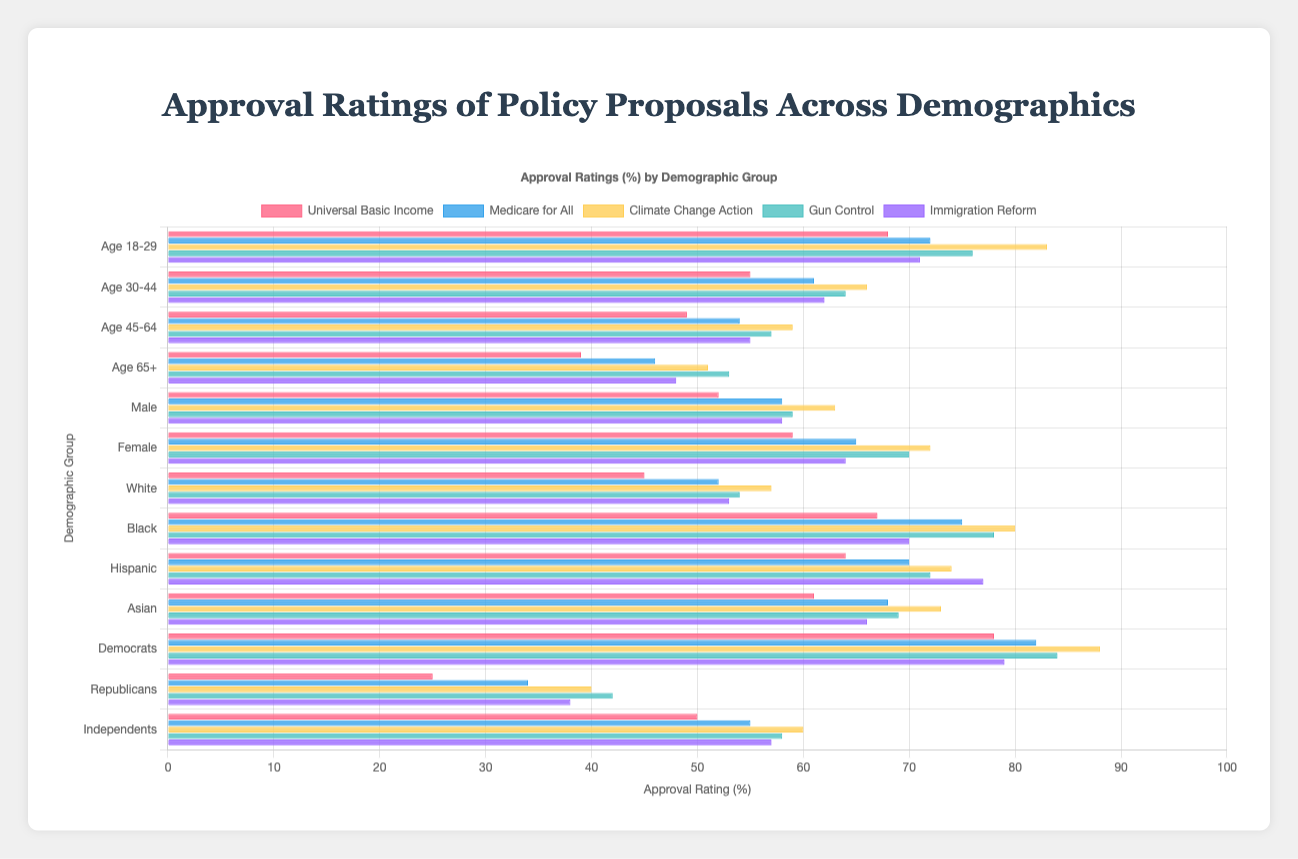What's the demographic group with the highest approval rating for Universal Basic Income? To find the highest approval rating for Universal Basic Income, look at the "Universal Basic Income" policy and then identify the demographic with the highest value, which is found to be "Age 18-29" with 68%.
Answer: Age 18-29 Which policy proposal has the lowest approval rating among Republicans? Identify the approval ratings for Republicans across all policy proposals. The lowest approval rating for Republicans is for "Universal Basic Income" with 25%.
Answer: Universal Basic Income What is the average approval rating for "Climate Change Action" across all age groups? Sum up the approval ratings for "Climate Change Action" across age groups (18-29, 30-44, 45-64, 65+): 83 + 66 + 59 + 51 = 259. Divide this by 4 (the number of age groups): 259 / 4 = 64.75
Answer: 64.75 Which policy has the highest approval rating overall and what is it? Look through the approval ratings for each policy proposal and identify the highest single value across all demographics. "Climate Change Action" has the highest approval rating with "Age 18-29" at 83%.
Answer: Climate Change Action at 83% How much higher is the approval rating for Gun Control among Democrats compared to Republicans? Subtract the approval rating for Republicans from that for Democrats for the "Gun Control" policy: 84% - 42% = 42%
Answer: 42% What is the difference in approval ratings for Medicare for All between males and females? Identify approval ratings for males and females for "Medicare for All". Subtract the male approval rating from the female approval rating: 65% - 58% = 7%
Answer: 7% Which demographic shows the greatest disparity in approval ratings between Medicare for All and Immigration Reform? Calculate the difference in approval ratings for both policies across different demographics and identify the one with the largest gap. The disparity for "Republicans" is the greatest, with a difference of 34% in Medicare for All and 38% in Immigration Reform:
Answer: Republicans (34% - 38%) = -4 What is the range of approval ratings for "Immigration Reform" among all age groups? Identify the highest and lowest approval ratings for "Immigration Reform" across all age demographics. Highest is "Age 18-29" at 71%, lowest is "Age 65+" at 48%. The range is 71% - 48% = 23%
Answer: 23% Which two policy proposals have the closest approval ratings among Independents? Compare the approval ratings among Independents across all policy proposals and identify the two closest values. "Gun Control" (58%) and "Climate Change Action" (60%) are the closest.
Answer: Gun Control and Climate Change Action 